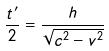Convert formula to latex. <formula><loc_0><loc_0><loc_500><loc_500>\frac { t ^ { \prime } } { 2 } = \frac { h } { \sqrt { c ^ { 2 } - v ^ { 2 } } }</formula> 